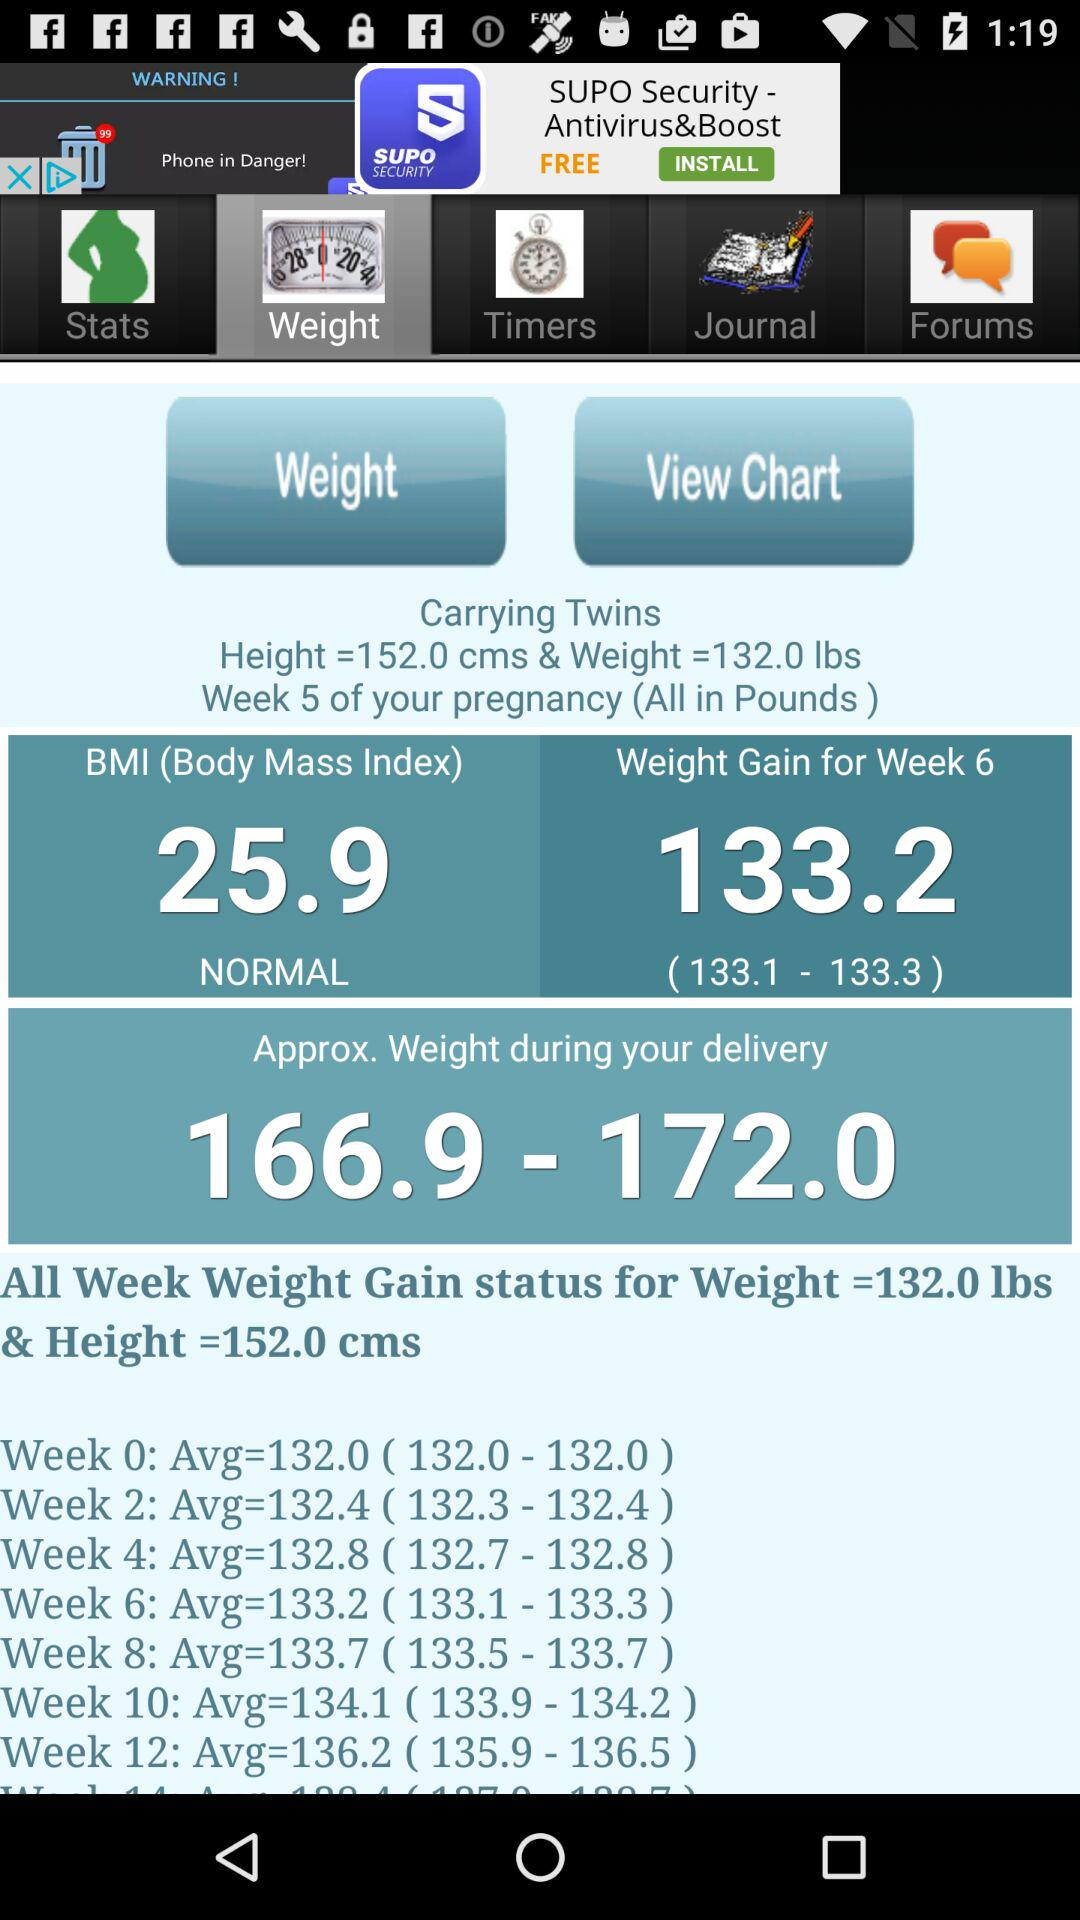When was the BMI record last updated?
When the provided information is insufficient, respond with <no answer>. <no answer> 